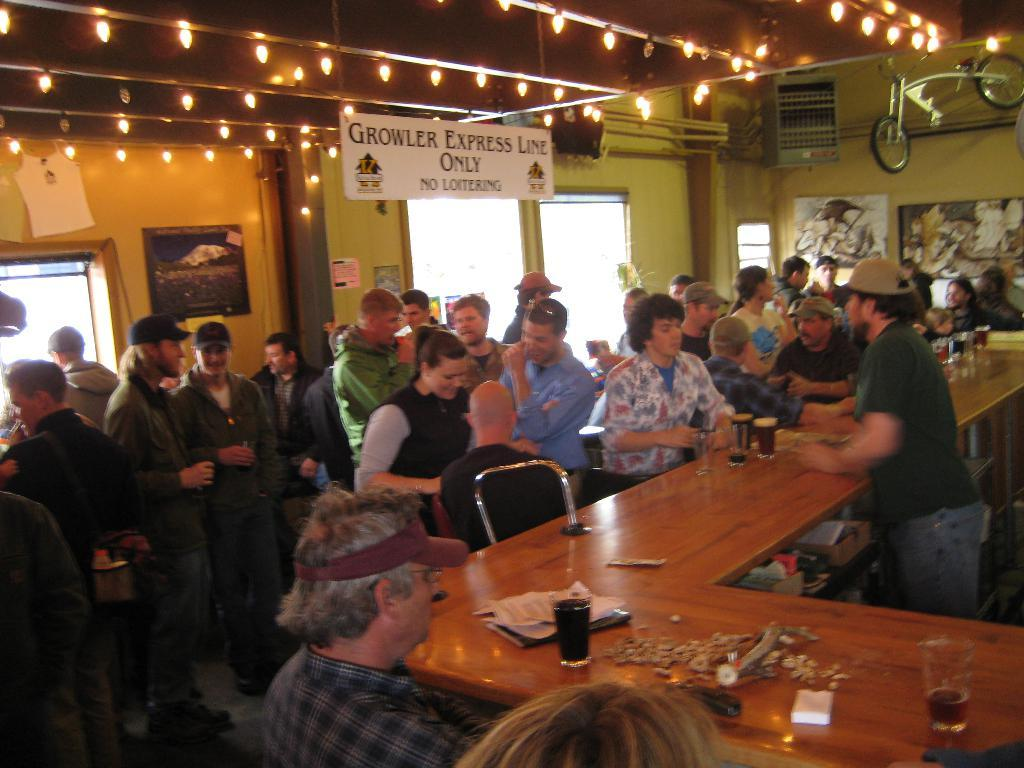How many people are in the group visible in the image? There is a group of people in the image, but the exact number cannot be determined without more specific information. What type of furniture is present in the image? There is a table in the image. What is on the table in the image? There is a glass, paper, and other objects on the table in the image. What type of sidewalk can be seen in the image? There is no sidewalk present in the image. What part of the table is the glass placed on? The glass is placed on the table, but it is not possible to determine which part of the table it is on without more specific information. 